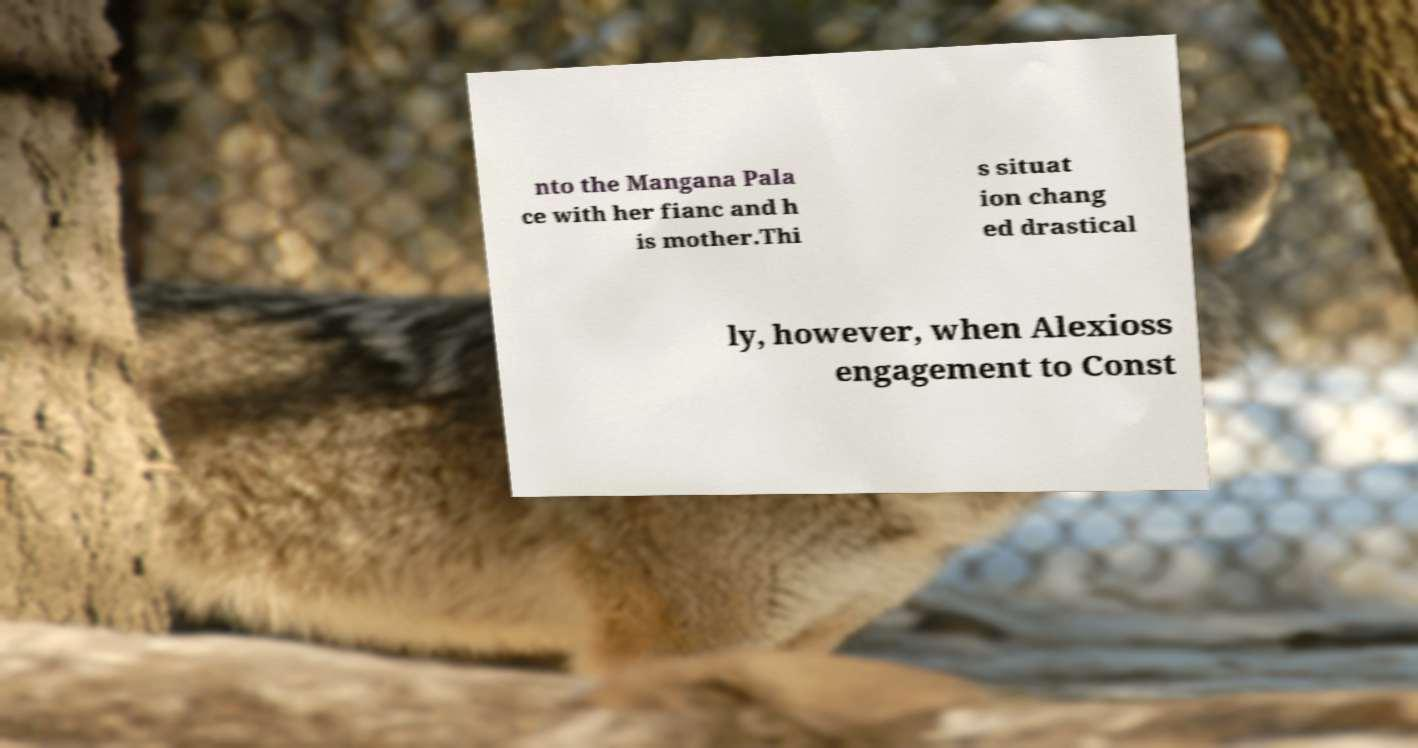I need the written content from this picture converted into text. Can you do that? nto the Mangana Pala ce with her fianc and h is mother.Thi s situat ion chang ed drastical ly, however, when Alexioss engagement to Const 